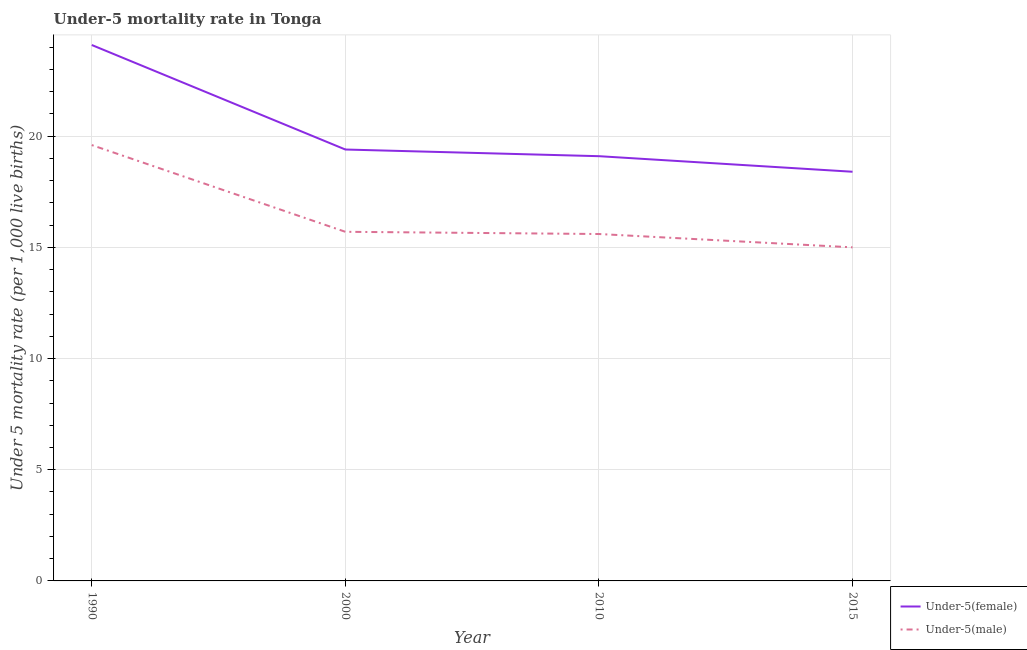How many different coloured lines are there?
Your response must be concise. 2. What is the under-5 female mortality rate in 2015?
Keep it short and to the point. 18.4. Across all years, what is the maximum under-5 female mortality rate?
Offer a very short reply. 24.1. In which year was the under-5 male mortality rate minimum?
Provide a short and direct response. 2015. What is the difference between the under-5 male mortality rate in 2000 and that in 2010?
Your response must be concise. 0.1. What is the difference between the under-5 female mortality rate in 2015 and the under-5 male mortality rate in 2000?
Your answer should be compact. 2.7. What is the average under-5 female mortality rate per year?
Give a very brief answer. 20.25. In the year 2010, what is the difference between the under-5 female mortality rate and under-5 male mortality rate?
Provide a succinct answer. 3.5. In how many years, is the under-5 male mortality rate greater than 20?
Offer a terse response. 0. What is the ratio of the under-5 female mortality rate in 1990 to that in 2000?
Give a very brief answer. 1.24. Is the under-5 male mortality rate in 2000 less than that in 2010?
Provide a succinct answer. No. What is the difference between the highest and the second highest under-5 female mortality rate?
Your response must be concise. 4.7. What is the difference between the highest and the lowest under-5 male mortality rate?
Offer a very short reply. 4.6. Is the under-5 male mortality rate strictly greater than the under-5 female mortality rate over the years?
Your answer should be compact. No. Is the under-5 female mortality rate strictly less than the under-5 male mortality rate over the years?
Keep it short and to the point. No. How many years are there in the graph?
Your answer should be compact. 4. What is the difference between two consecutive major ticks on the Y-axis?
Provide a succinct answer. 5. Are the values on the major ticks of Y-axis written in scientific E-notation?
Your response must be concise. No. Does the graph contain grids?
Offer a terse response. Yes. Where does the legend appear in the graph?
Your answer should be very brief. Bottom right. What is the title of the graph?
Give a very brief answer. Under-5 mortality rate in Tonga. What is the label or title of the X-axis?
Keep it short and to the point. Year. What is the label or title of the Y-axis?
Your response must be concise. Under 5 mortality rate (per 1,0 live births). What is the Under 5 mortality rate (per 1,000 live births) in Under-5(female) in 1990?
Your response must be concise. 24.1. What is the Under 5 mortality rate (per 1,000 live births) of Under-5(male) in 1990?
Keep it short and to the point. 19.6. What is the Under 5 mortality rate (per 1,000 live births) of Under-5(female) in 2000?
Offer a terse response. 19.4. What is the Under 5 mortality rate (per 1,000 live births) in Under-5(male) in 2000?
Your answer should be very brief. 15.7. What is the Under 5 mortality rate (per 1,000 live births) of Under-5(female) in 2010?
Offer a terse response. 19.1. What is the Under 5 mortality rate (per 1,000 live births) in Under-5(female) in 2015?
Give a very brief answer. 18.4. Across all years, what is the maximum Under 5 mortality rate (per 1,000 live births) of Under-5(female)?
Your answer should be compact. 24.1. Across all years, what is the maximum Under 5 mortality rate (per 1,000 live births) of Under-5(male)?
Your answer should be compact. 19.6. Across all years, what is the minimum Under 5 mortality rate (per 1,000 live births) in Under-5(female)?
Keep it short and to the point. 18.4. Across all years, what is the minimum Under 5 mortality rate (per 1,000 live births) of Under-5(male)?
Offer a terse response. 15. What is the total Under 5 mortality rate (per 1,000 live births) of Under-5(male) in the graph?
Provide a short and direct response. 65.9. What is the difference between the Under 5 mortality rate (per 1,000 live births) of Under-5(female) in 1990 and that in 2000?
Keep it short and to the point. 4.7. What is the difference between the Under 5 mortality rate (per 1,000 live births) of Under-5(male) in 1990 and that in 2000?
Offer a very short reply. 3.9. What is the difference between the Under 5 mortality rate (per 1,000 live births) in Under-5(female) in 1990 and that in 2010?
Give a very brief answer. 5. What is the difference between the Under 5 mortality rate (per 1,000 live births) of Under-5(male) in 1990 and that in 2010?
Give a very brief answer. 4. What is the difference between the Under 5 mortality rate (per 1,000 live births) in Under-5(female) in 1990 and that in 2015?
Provide a short and direct response. 5.7. What is the difference between the Under 5 mortality rate (per 1,000 live births) in Under-5(male) in 2000 and that in 2010?
Your response must be concise. 0.1. What is the difference between the Under 5 mortality rate (per 1,000 live births) in Under-5(female) in 2000 and that in 2015?
Offer a terse response. 1. What is the difference between the Under 5 mortality rate (per 1,000 live births) in Under-5(male) in 2000 and that in 2015?
Offer a terse response. 0.7. What is the difference between the Under 5 mortality rate (per 1,000 live births) of Under-5(female) in 2010 and that in 2015?
Offer a terse response. 0.7. What is the difference between the Under 5 mortality rate (per 1,000 live births) of Under-5(male) in 2010 and that in 2015?
Give a very brief answer. 0.6. What is the difference between the Under 5 mortality rate (per 1,000 live births) in Under-5(female) in 2000 and the Under 5 mortality rate (per 1,000 live births) in Under-5(male) in 2015?
Your response must be concise. 4.4. What is the difference between the Under 5 mortality rate (per 1,000 live births) in Under-5(female) in 2010 and the Under 5 mortality rate (per 1,000 live births) in Under-5(male) in 2015?
Give a very brief answer. 4.1. What is the average Under 5 mortality rate (per 1,000 live births) of Under-5(female) per year?
Provide a succinct answer. 20.25. What is the average Under 5 mortality rate (per 1,000 live births) in Under-5(male) per year?
Offer a terse response. 16.48. In the year 1990, what is the difference between the Under 5 mortality rate (per 1,000 live births) of Under-5(female) and Under 5 mortality rate (per 1,000 live births) of Under-5(male)?
Make the answer very short. 4.5. In the year 2000, what is the difference between the Under 5 mortality rate (per 1,000 live births) in Under-5(female) and Under 5 mortality rate (per 1,000 live births) in Under-5(male)?
Offer a terse response. 3.7. In the year 2015, what is the difference between the Under 5 mortality rate (per 1,000 live births) of Under-5(female) and Under 5 mortality rate (per 1,000 live births) of Under-5(male)?
Your response must be concise. 3.4. What is the ratio of the Under 5 mortality rate (per 1,000 live births) of Under-5(female) in 1990 to that in 2000?
Offer a terse response. 1.24. What is the ratio of the Under 5 mortality rate (per 1,000 live births) in Under-5(male) in 1990 to that in 2000?
Provide a short and direct response. 1.25. What is the ratio of the Under 5 mortality rate (per 1,000 live births) of Under-5(female) in 1990 to that in 2010?
Make the answer very short. 1.26. What is the ratio of the Under 5 mortality rate (per 1,000 live births) in Under-5(male) in 1990 to that in 2010?
Provide a succinct answer. 1.26. What is the ratio of the Under 5 mortality rate (per 1,000 live births) in Under-5(female) in 1990 to that in 2015?
Your answer should be very brief. 1.31. What is the ratio of the Under 5 mortality rate (per 1,000 live births) in Under-5(male) in 1990 to that in 2015?
Provide a short and direct response. 1.31. What is the ratio of the Under 5 mortality rate (per 1,000 live births) in Under-5(female) in 2000 to that in 2010?
Your response must be concise. 1.02. What is the ratio of the Under 5 mortality rate (per 1,000 live births) of Under-5(male) in 2000 to that in 2010?
Give a very brief answer. 1.01. What is the ratio of the Under 5 mortality rate (per 1,000 live births) of Under-5(female) in 2000 to that in 2015?
Provide a succinct answer. 1.05. What is the ratio of the Under 5 mortality rate (per 1,000 live births) of Under-5(male) in 2000 to that in 2015?
Your answer should be very brief. 1.05. What is the ratio of the Under 5 mortality rate (per 1,000 live births) in Under-5(female) in 2010 to that in 2015?
Make the answer very short. 1.04. What is the ratio of the Under 5 mortality rate (per 1,000 live births) of Under-5(male) in 2010 to that in 2015?
Ensure brevity in your answer.  1.04. What is the difference between the highest and the second highest Under 5 mortality rate (per 1,000 live births) in Under-5(male)?
Your response must be concise. 3.9. What is the difference between the highest and the lowest Under 5 mortality rate (per 1,000 live births) in Under-5(female)?
Your answer should be very brief. 5.7. What is the difference between the highest and the lowest Under 5 mortality rate (per 1,000 live births) in Under-5(male)?
Give a very brief answer. 4.6. 